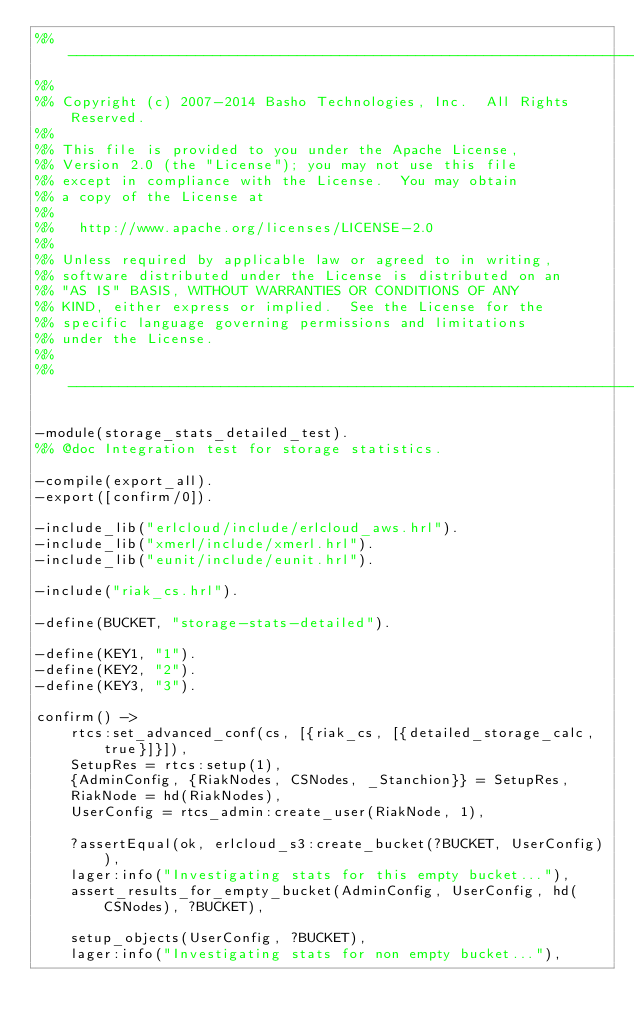Convert code to text. <code><loc_0><loc_0><loc_500><loc_500><_Erlang_>%% ---------------------------------------------------------------------
%%
%% Copyright (c) 2007-2014 Basho Technologies, Inc.  All Rights Reserved.
%%
%% This file is provided to you under the Apache License,
%% Version 2.0 (the "License"); you may not use this file
%% except in compliance with the License.  You may obtain
%% a copy of the License at
%%
%%   http://www.apache.org/licenses/LICENSE-2.0
%%
%% Unless required by applicable law or agreed to in writing,
%% software distributed under the License is distributed on an
%% "AS IS" BASIS, WITHOUT WARRANTIES OR CONDITIONS OF ANY
%% KIND, either express or implied.  See the License for the
%% specific language governing permissions and limitations
%% under the License.
%%
%% ---------------------------------------------------------------------

-module(storage_stats_detailed_test).
%% @doc Integration test for storage statistics.

-compile(export_all).
-export([confirm/0]).

-include_lib("erlcloud/include/erlcloud_aws.hrl").
-include_lib("xmerl/include/xmerl.hrl").
-include_lib("eunit/include/eunit.hrl").

-include("riak_cs.hrl").

-define(BUCKET, "storage-stats-detailed").

-define(KEY1, "1").
-define(KEY2, "2").
-define(KEY3, "3").

confirm() ->
    rtcs:set_advanced_conf(cs, [{riak_cs, [{detailed_storage_calc, true}]}]),
    SetupRes = rtcs:setup(1),
    {AdminConfig, {RiakNodes, CSNodes, _Stanchion}} = SetupRes,
    RiakNode = hd(RiakNodes),
    UserConfig = rtcs_admin:create_user(RiakNode, 1),

    ?assertEqual(ok, erlcloud_s3:create_bucket(?BUCKET, UserConfig)),
    lager:info("Investigating stats for this empty bucket..."),
    assert_results_for_empty_bucket(AdminConfig, UserConfig, hd(CSNodes), ?BUCKET),

    setup_objects(UserConfig, ?BUCKET),
    lager:info("Investigating stats for non empty bucket..."),</code> 